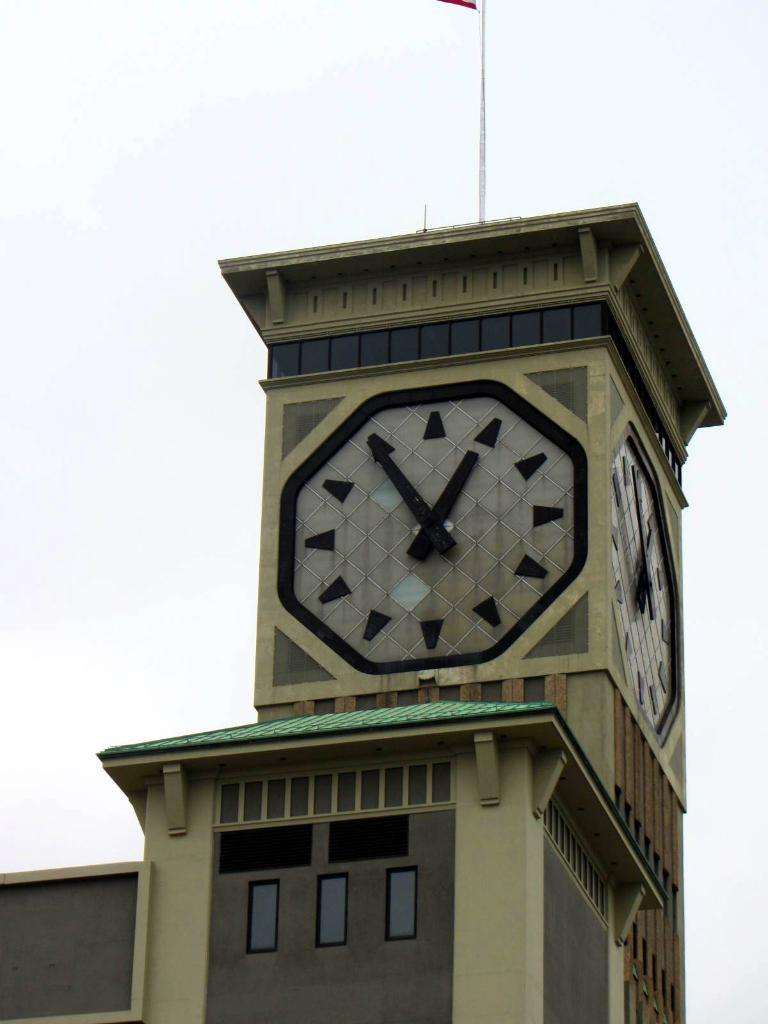What is the main structure in the image? There is a clock tower in the image. What is the color of the background in the image? The clock tower is on a white background. What can be seen at the top of the image? There is a pole at the top of the image. How do the giants interact with the clock tower in the image? There are no giants present in the image, so it is not possible to determine how they might interact with the clock tower. 